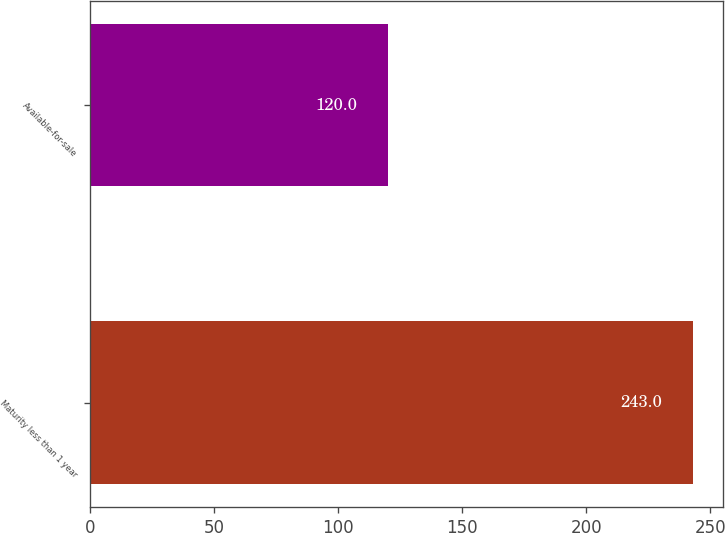Convert chart to OTSL. <chart><loc_0><loc_0><loc_500><loc_500><bar_chart><fcel>Maturity less than 1 year<fcel>Available-for-sale<nl><fcel>243<fcel>120<nl></chart> 